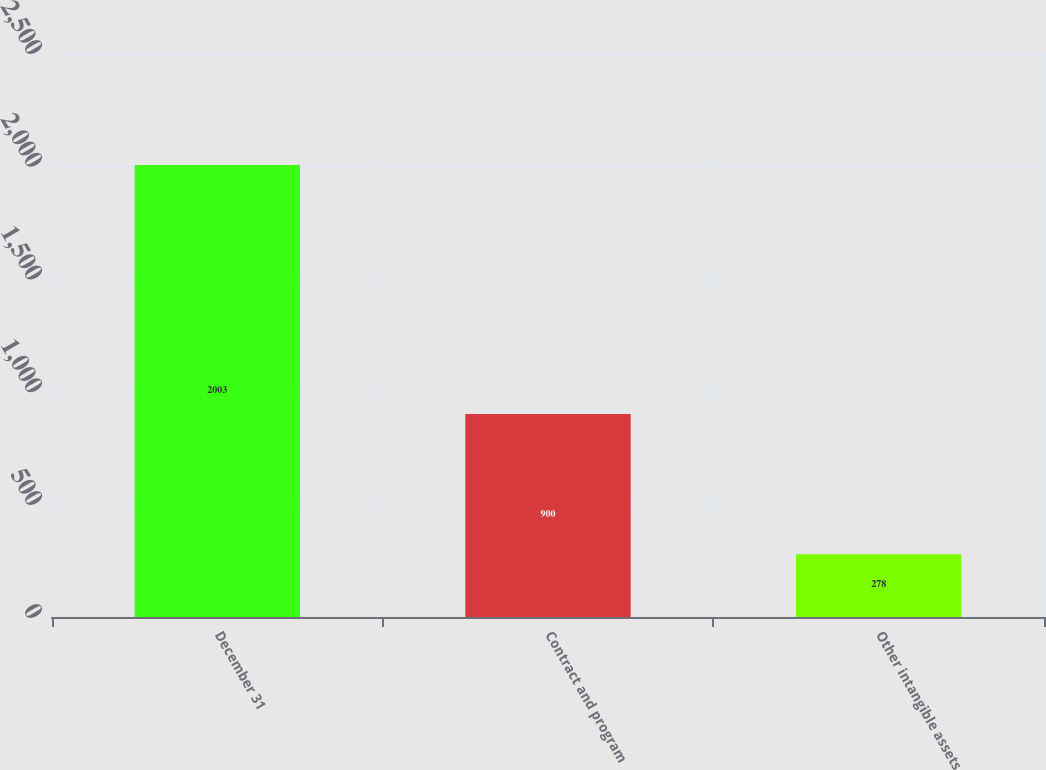<chart> <loc_0><loc_0><loc_500><loc_500><bar_chart><fcel>December 31<fcel>Contract and program<fcel>Other intangible assets<nl><fcel>2003<fcel>900<fcel>278<nl></chart> 